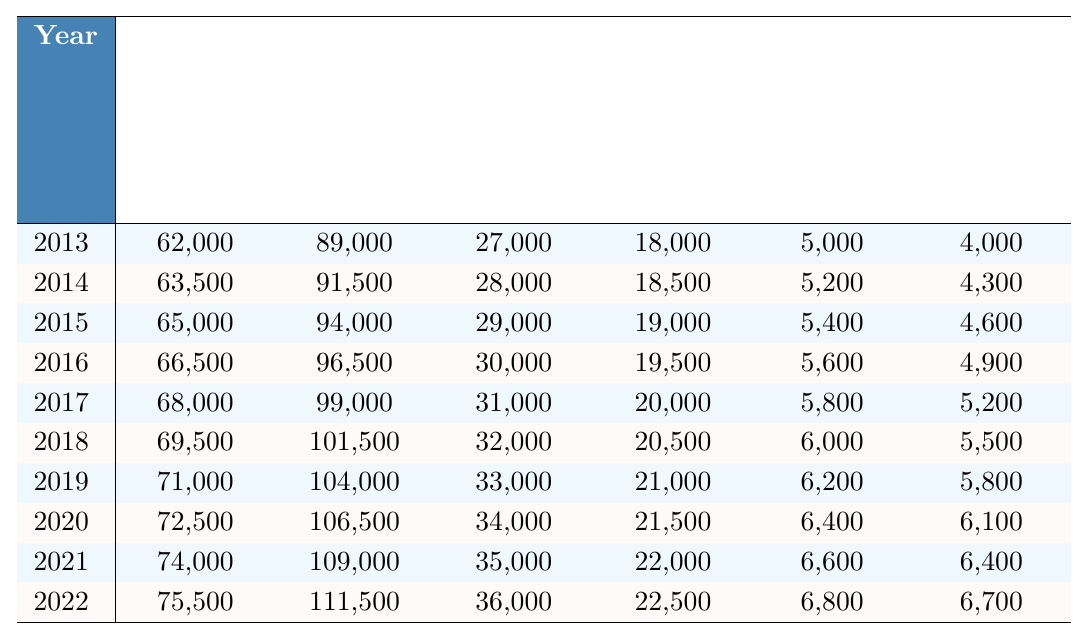What was the total cost of living in 2019 with a stay-at-home parent? The table shows that the cost with a stay-at-home parent in 2019 was $71,000.
Answer: $71,000 How much did the cost of living without a stay-at-home parent increase from 2013 to 2022? The cost without a stay-at-home parent in 2013 was $89,000 and in 2022 it was $111,500. The increase is $111,500 - $89,000 = $22,500.
Answer: $22,500 What is the average difference in costs between having and not having a stay-at-home parent from 2020 to 2022? The differences from 2020 to 2022 are $34,000, $35,000, and $36,000. The average is (34,000 + 35,000 + 36,000) / 3 = $35,000.
Answer: $35,000 Did the childcare costs ever decrease from 2013 to 2022? By examining the childcare costs from 2013 to 2022, we see that they increased each year, starting at $18,000 in 2013 and reaching $22,500 in 2022.
Answer: No What percentage of the total cost with a stay-at-home parent was saved in transportation costs in 2017? The total cost with a stay-at-home parent in 2017 was $68,000, and transportation savings were $5,200. The percentage saved is ($5,200 / $68,000) * 100 = 7.65%.
Answer: 7.65% What was the change in household management savings from 2015 to 2021? The household management savings in 2015 were $5,400, and in 2021, they were $6,600. The change is $6,600 - $5,400 = $1,200.
Answer: $1,200 How much more cost-effective was it to have a stay-at-home parent in 2018 compared to 2013? In 2018, the cost with a stay-at-home parent was $69,500, and in 2013 it was $62,000. The difference is $69,500 - $62,000 = $7,500. This indicates that the cost with a stay-at-home parent increased by $7,500 over that period.
Answer: $7,500 What was the total savings in household management across all years in the table? The household management savings for each year were: $5,000, $5,200, $5,400, $5,600, $5,800, $6,000, $6,200, $6,400, $6,600, and $6,800. Adding them together gives $57,200.
Answer: $57,200 In which year was the cost difference between having and not having a stay-at-home parent the greatest? By reviewing the "Difference" column, we find the highest value was $36,000 in 2022.
Answer: 2022 How did the transportation savings in 2014 compare to the transportation savings in 2019? Transportation savings in 2014 were $4,300, and in 2019, they were $5,800. The difference is $5,800 - $4,300 = $1,500, indicating an increase.
Answer: Increased by $1,500 What is the trend of costs with a stay-at-home parent over the decade? The costs with a stay-at-home parent increased every year from $62,000 in 2013 to $75,500 in 2022, showing a consistent upward trend.
Answer: Consistent upward trend 